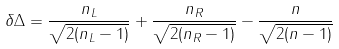Convert formula to latex. <formula><loc_0><loc_0><loc_500><loc_500>\delta \Delta = \frac { n _ { L } } { \sqrt { 2 ( n _ { L } - 1 ) } } + \frac { n _ { R } } { \sqrt { 2 ( n _ { R } - 1 ) } } - \frac { n } { \sqrt { 2 ( n - 1 ) } }</formula> 